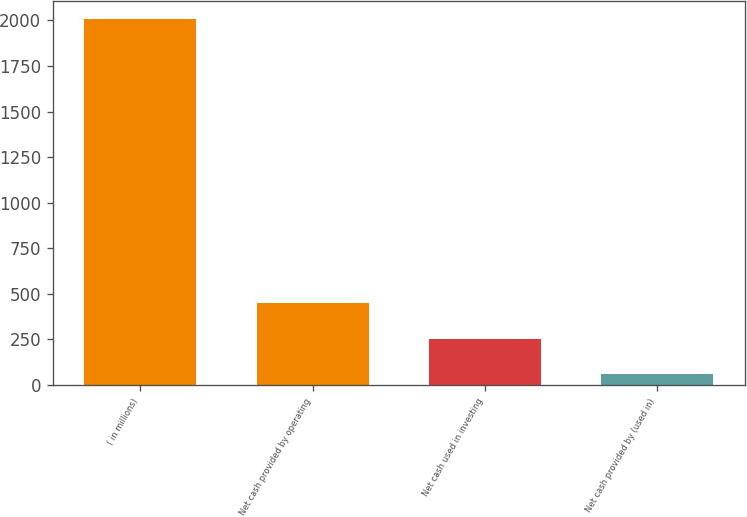Convert chart to OTSL. <chart><loc_0><loc_0><loc_500><loc_500><bar_chart><fcel>( in millions)<fcel>Net cash provided by operating<fcel>Net cash used in investing<fcel>Net cash provided by (used in)<nl><fcel>2006<fcel>449.36<fcel>254.78<fcel>60.2<nl></chart> 